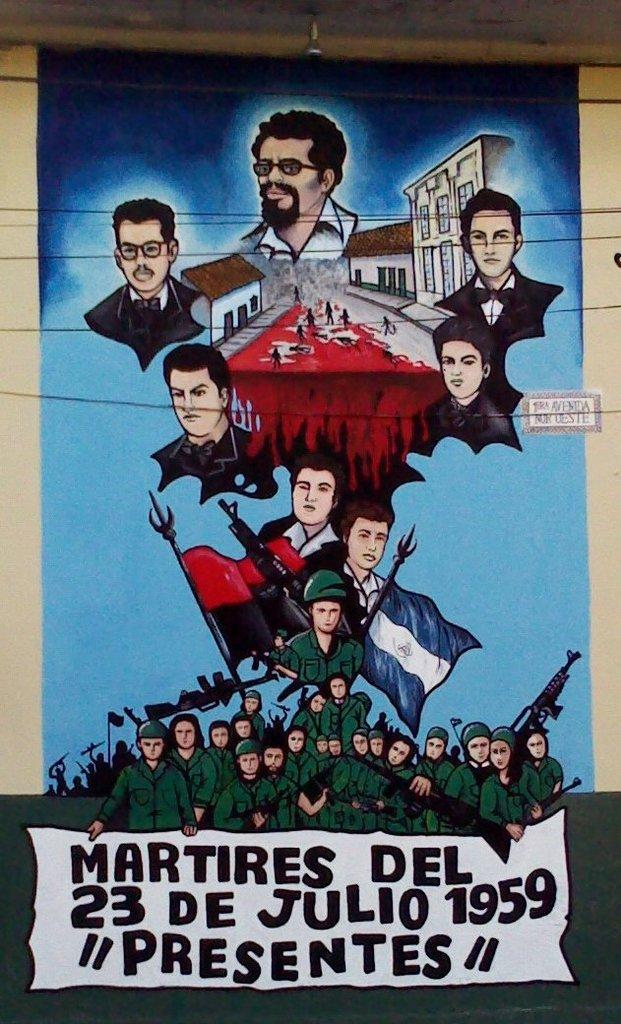<image>
Give a short and clear explanation of the subsequent image. Military people are on the bottom of a sign with 23 de Julio 1959. 